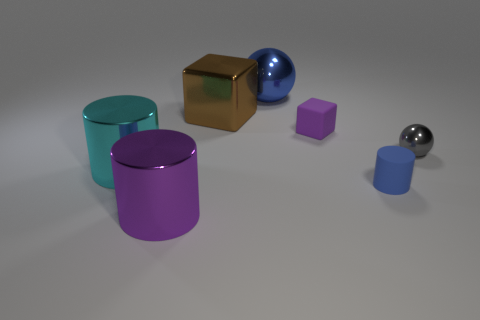What number of objects are shiny objects or large cylinders behind the purple metallic object?
Provide a succinct answer. 5. What shape is the big thing that is the same color as the small cube?
Ensure brevity in your answer.  Cylinder. How many brown cubes are the same size as the blue matte object?
Offer a terse response. 0. What number of blue objects are tiny objects or large shiny balls?
Ensure brevity in your answer.  2. What shape is the purple thing that is to the right of the object that is in front of the small blue thing?
Ensure brevity in your answer.  Cube. The purple rubber object that is the same size as the gray thing is what shape?
Your response must be concise. Cube. Are there any large cubes of the same color as the rubber cylinder?
Your response must be concise. No. Are there the same number of metal cylinders that are behind the purple metal cylinder and gray metallic things that are behind the cyan metallic cylinder?
Keep it short and to the point. Yes. Is the shape of the purple matte thing the same as the purple object that is in front of the cyan shiny cylinder?
Give a very brief answer. No. How many other objects are the same material as the big blue ball?
Give a very brief answer. 4. 